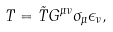Convert formula to latex. <formula><loc_0><loc_0><loc_500><loc_500>T = \tilde { T } G ^ { \mu \nu } \sigma _ { \mu } \epsilon _ { \nu } ,</formula> 